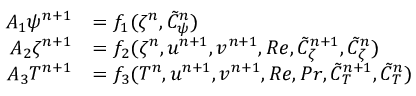Convert formula to latex. <formula><loc_0><loc_0><loc_500><loc_500>\begin{array} { r l } { A _ { 1 } \psi ^ { n + 1 } } & { = f _ { 1 } ( \zeta ^ { n } , \tilde { C } _ { \psi } ^ { n } ) } \\ { A _ { 2 } \zeta ^ { n + 1 } } & { = f _ { 2 } ( \zeta ^ { n } , u ^ { n + 1 } , v ^ { n + 1 } , R e , \tilde { C } _ { \zeta } ^ { n + 1 } , \tilde { C } _ { \zeta } ^ { n } ) } \\ { A _ { 3 } T ^ { n + 1 } } & { = f _ { 3 } ( T ^ { n } , u ^ { n + 1 } , v ^ { n + 1 } , R e , P r , \tilde { C } _ { T } ^ { n + 1 } , \tilde { C } _ { T } ^ { n } ) } \end{array}</formula> 